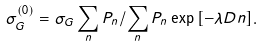<formula> <loc_0><loc_0><loc_500><loc_500>\sigma _ { G } ^ { ( 0 ) } = \sigma _ { G } \sum _ { n } P _ { n } / \sum _ { n } P _ { n } \exp { [ - \lambda D n ] } .</formula> 